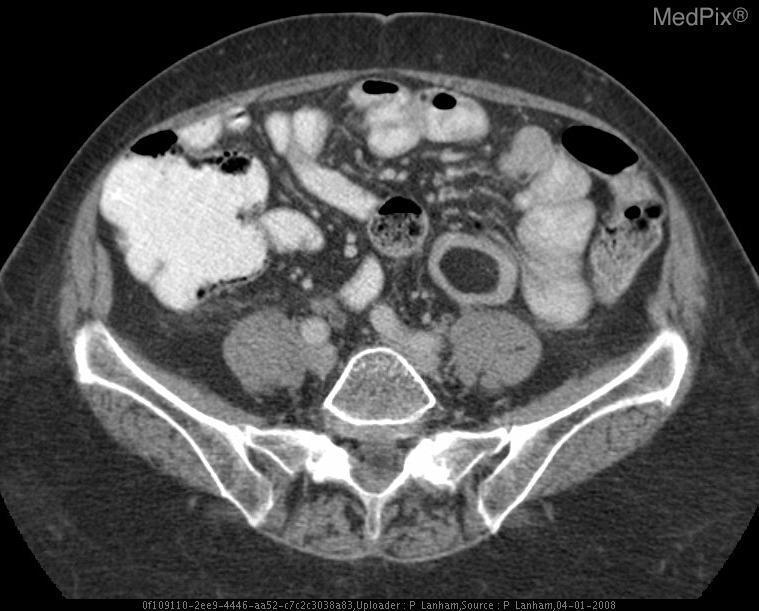Is the abdomen distended?
Give a very brief answer. No. Is there a cyst in the right kidney?
Answer briefly. No. Is it contrast these hyperintensities in the intestines?
Answer briefly. Yes. 